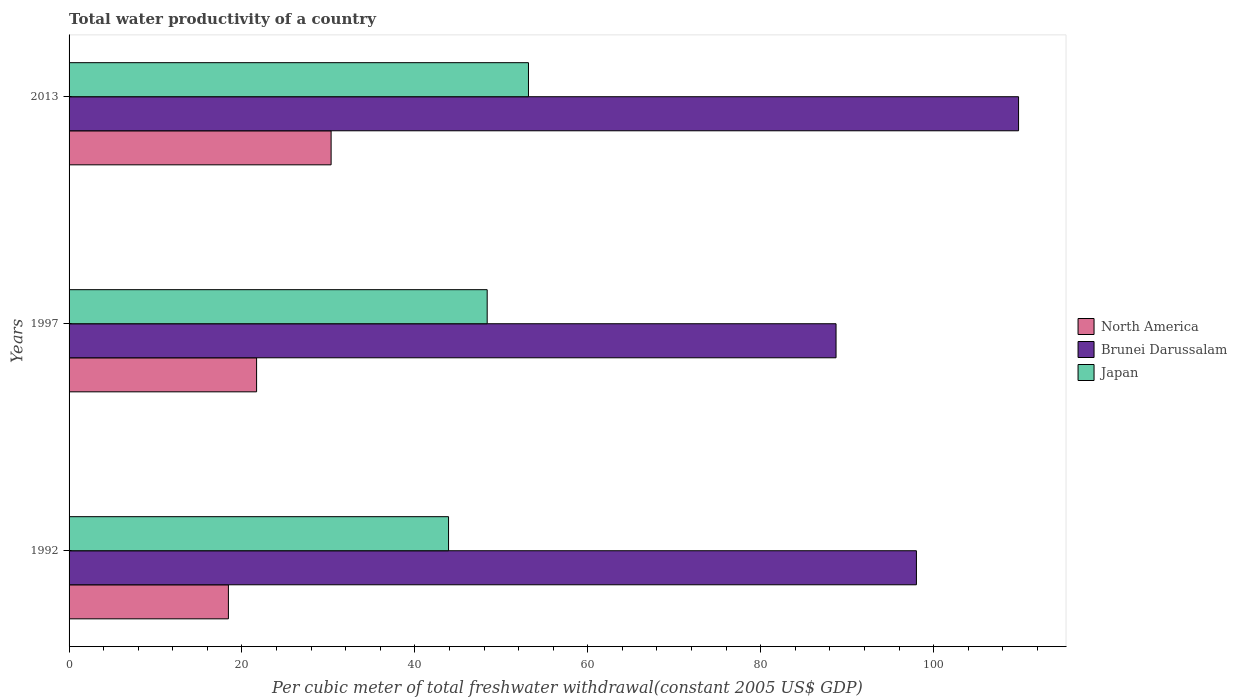How many different coloured bars are there?
Your answer should be compact. 3. How many bars are there on the 2nd tick from the top?
Give a very brief answer. 3. How many bars are there on the 1st tick from the bottom?
Ensure brevity in your answer.  3. In how many cases, is the number of bars for a given year not equal to the number of legend labels?
Ensure brevity in your answer.  0. What is the total water productivity in Brunei Darussalam in 1992?
Provide a succinct answer. 98.01. Across all years, what is the maximum total water productivity in Brunei Darussalam?
Give a very brief answer. 109.83. Across all years, what is the minimum total water productivity in Brunei Darussalam?
Your answer should be very brief. 88.71. What is the total total water productivity in Brunei Darussalam in the graph?
Keep it short and to the point. 296.55. What is the difference between the total water productivity in Brunei Darussalam in 1992 and that in 1997?
Provide a succinct answer. 9.3. What is the difference between the total water productivity in Japan in 1992 and the total water productivity in Brunei Darussalam in 2013?
Make the answer very short. -65.93. What is the average total water productivity in North America per year?
Your answer should be compact. 23.48. In the year 1992, what is the difference between the total water productivity in Japan and total water productivity in Brunei Darussalam?
Provide a succinct answer. -54.12. In how many years, is the total water productivity in North America greater than 92 US$?
Give a very brief answer. 0. What is the ratio of the total water productivity in Brunei Darussalam in 1992 to that in 2013?
Keep it short and to the point. 0.89. Is the difference between the total water productivity in Japan in 1992 and 2013 greater than the difference between the total water productivity in Brunei Darussalam in 1992 and 2013?
Ensure brevity in your answer.  Yes. What is the difference between the highest and the second highest total water productivity in Brunei Darussalam?
Offer a terse response. 11.81. What is the difference between the highest and the lowest total water productivity in Brunei Darussalam?
Your answer should be compact. 21.11. In how many years, is the total water productivity in Brunei Darussalam greater than the average total water productivity in Brunei Darussalam taken over all years?
Your answer should be compact. 1. What does the 2nd bar from the bottom in 1992 represents?
Provide a succinct answer. Brunei Darussalam. Is it the case that in every year, the sum of the total water productivity in Brunei Darussalam and total water productivity in North America is greater than the total water productivity in Japan?
Offer a very short reply. Yes. Are all the bars in the graph horizontal?
Provide a short and direct response. Yes. How many years are there in the graph?
Keep it short and to the point. 3. Does the graph contain any zero values?
Your response must be concise. No. Does the graph contain grids?
Offer a terse response. No. Where does the legend appear in the graph?
Provide a short and direct response. Center right. How many legend labels are there?
Ensure brevity in your answer.  3. How are the legend labels stacked?
Ensure brevity in your answer.  Vertical. What is the title of the graph?
Your response must be concise. Total water productivity of a country. What is the label or title of the X-axis?
Give a very brief answer. Per cubic meter of total freshwater withdrawal(constant 2005 US$ GDP). What is the Per cubic meter of total freshwater withdrawal(constant 2005 US$ GDP) in North America in 1992?
Provide a succinct answer. 18.43. What is the Per cubic meter of total freshwater withdrawal(constant 2005 US$ GDP) in Brunei Darussalam in 1992?
Your answer should be very brief. 98.01. What is the Per cubic meter of total freshwater withdrawal(constant 2005 US$ GDP) in Japan in 1992?
Make the answer very short. 43.89. What is the Per cubic meter of total freshwater withdrawal(constant 2005 US$ GDP) of North America in 1997?
Ensure brevity in your answer.  21.69. What is the Per cubic meter of total freshwater withdrawal(constant 2005 US$ GDP) of Brunei Darussalam in 1997?
Offer a very short reply. 88.71. What is the Per cubic meter of total freshwater withdrawal(constant 2005 US$ GDP) in Japan in 1997?
Your answer should be very brief. 48.36. What is the Per cubic meter of total freshwater withdrawal(constant 2005 US$ GDP) of North America in 2013?
Your answer should be very brief. 30.31. What is the Per cubic meter of total freshwater withdrawal(constant 2005 US$ GDP) of Brunei Darussalam in 2013?
Your answer should be very brief. 109.83. What is the Per cubic meter of total freshwater withdrawal(constant 2005 US$ GDP) in Japan in 2013?
Offer a very short reply. 53.14. Across all years, what is the maximum Per cubic meter of total freshwater withdrawal(constant 2005 US$ GDP) of North America?
Your response must be concise. 30.31. Across all years, what is the maximum Per cubic meter of total freshwater withdrawal(constant 2005 US$ GDP) in Brunei Darussalam?
Offer a very short reply. 109.83. Across all years, what is the maximum Per cubic meter of total freshwater withdrawal(constant 2005 US$ GDP) of Japan?
Offer a very short reply. 53.14. Across all years, what is the minimum Per cubic meter of total freshwater withdrawal(constant 2005 US$ GDP) in North America?
Offer a very short reply. 18.43. Across all years, what is the minimum Per cubic meter of total freshwater withdrawal(constant 2005 US$ GDP) in Brunei Darussalam?
Your response must be concise. 88.71. Across all years, what is the minimum Per cubic meter of total freshwater withdrawal(constant 2005 US$ GDP) in Japan?
Give a very brief answer. 43.89. What is the total Per cubic meter of total freshwater withdrawal(constant 2005 US$ GDP) in North America in the graph?
Offer a very short reply. 70.43. What is the total Per cubic meter of total freshwater withdrawal(constant 2005 US$ GDP) in Brunei Darussalam in the graph?
Offer a very short reply. 296.55. What is the total Per cubic meter of total freshwater withdrawal(constant 2005 US$ GDP) of Japan in the graph?
Keep it short and to the point. 145.39. What is the difference between the Per cubic meter of total freshwater withdrawal(constant 2005 US$ GDP) of North America in 1992 and that in 1997?
Keep it short and to the point. -3.26. What is the difference between the Per cubic meter of total freshwater withdrawal(constant 2005 US$ GDP) in Brunei Darussalam in 1992 and that in 1997?
Make the answer very short. 9.3. What is the difference between the Per cubic meter of total freshwater withdrawal(constant 2005 US$ GDP) of Japan in 1992 and that in 1997?
Offer a terse response. -4.47. What is the difference between the Per cubic meter of total freshwater withdrawal(constant 2005 US$ GDP) in North America in 1992 and that in 2013?
Ensure brevity in your answer.  -11.88. What is the difference between the Per cubic meter of total freshwater withdrawal(constant 2005 US$ GDP) in Brunei Darussalam in 1992 and that in 2013?
Ensure brevity in your answer.  -11.81. What is the difference between the Per cubic meter of total freshwater withdrawal(constant 2005 US$ GDP) of Japan in 1992 and that in 2013?
Your response must be concise. -9.24. What is the difference between the Per cubic meter of total freshwater withdrawal(constant 2005 US$ GDP) of North America in 1997 and that in 2013?
Offer a very short reply. -8.62. What is the difference between the Per cubic meter of total freshwater withdrawal(constant 2005 US$ GDP) of Brunei Darussalam in 1997 and that in 2013?
Provide a short and direct response. -21.11. What is the difference between the Per cubic meter of total freshwater withdrawal(constant 2005 US$ GDP) in Japan in 1997 and that in 2013?
Offer a terse response. -4.78. What is the difference between the Per cubic meter of total freshwater withdrawal(constant 2005 US$ GDP) of North America in 1992 and the Per cubic meter of total freshwater withdrawal(constant 2005 US$ GDP) of Brunei Darussalam in 1997?
Make the answer very short. -70.28. What is the difference between the Per cubic meter of total freshwater withdrawal(constant 2005 US$ GDP) of North America in 1992 and the Per cubic meter of total freshwater withdrawal(constant 2005 US$ GDP) of Japan in 1997?
Offer a very short reply. -29.93. What is the difference between the Per cubic meter of total freshwater withdrawal(constant 2005 US$ GDP) in Brunei Darussalam in 1992 and the Per cubic meter of total freshwater withdrawal(constant 2005 US$ GDP) in Japan in 1997?
Provide a short and direct response. 49.65. What is the difference between the Per cubic meter of total freshwater withdrawal(constant 2005 US$ GDP) of North America in 1992 and the Per cubic meter of total freshwater withdrawal(constant 2005 US$ GDP) of Brunei Darussalam in 2013?
Your answer should be compact. -91.4. What is the difference between the Per cubic meter of total freshwater withdrawal(constant 2005 US$ GDP) of North America in 1992 and the Per cubic meter of total freshwater withdrawal(constant 2005 US$ GDP) of Japan in 2013?
Offer a very short reply. -34.71. What is the difference between the Per cubic meter of total freshwater withdrawal(constant 2005 US$ GDP) of Brunei Darussalam in 1992 and the Per cubic meter of total freshwater withdrawal(constant 2005 US$ GDP) of Japan in 2013?
Offer a terse response. 44.87. What is the difference between the Per cubic meter of total freshwater withdrawal(constant 2005 US$ GDP) in North America in 1997 and the Per cubic meter of total freshwater withdrawal(constant 2005 US$ GDP) in Brunei Darussalam in 2013?
Your answer should be very brief. -88.14. What is the difference between the Per cubic meter of total freshwater withdrawal(constant 2005 US$ GDP) of North America in 1997 and the Per cubic meter of total freshwater withdrawal(constant 2005 US$ GDP) of Japan in 2013?
Provide a short and direct response. -31.45. What is the difference between the Per cubic meter of total freshwater withdrawal(constant 2005 US$ GDP) in Brunei Darussalam in 1997 and the Per cubic meter of total freshwater withdrawal(constant 2005 US$ GDP) in Japan in 2013?
Your response must be concise. 35.58. What is the average Per cubic meter of total freshwater withdrawal(constant 2005 US$ GDP) in North America per year?
Offer a terse response. 23.48. What is the average Per cubic meter of total freshwater withdrawal(constant 2005 US$ GDP) of Brunei Darussalam per year?
Offer a very short reply. 98.85. What is the average Per cubic meter of total freshwater withdrawal(constant 2005 US$ GDP) of Japan per year?
Ensure brevity in your answer.  48.46. In the year 1992, what is the difference between the Per cubic meter of total freshwater withdrawal(constant 2005 US$ GDP) of North America and Per cubic meter of total freshwater withdrawal(constant 2005 US$ GDP) of Brunei Darussalam?
Your answer should be compact. -79.58. In the year 1992, what is the difference between the Per cubic meter of total freshwater withdrawal(constant 2005 US$ GDP) in North America and Per cubic meter of total freshwater withdrawal(constant 2005 US$ GDP) in Japan?
Ensure brevity in your answer.  -25.46. In the year 1992, what is the difference between the Per cubic meter of total freshwater withdrawal(constant 2005 US$ GDP) of Brunei Darussalam and Per cubic meter of total freshwater withdrawal(constant 2005 US$ GDP) of Japan?
Make the answer very short. 54.12. In the year 1997, what is the difference between the Per cubic meter of total freshwater withdrawal(constant 2005 US$ GDP) in North America and Per cubic meter of total freshwater withdrawal(constant 2005 US$ GDP) in Brunei Darussalam?
Keep it short and to the point. -67.02. In the year 1997, what is the difference between the Per cubic meter of total freshwater withdrawal(constant 2005 US$ GDP) of North America and Per cubic meter of total freshwater withdrawal(constant 2005 US$ GDP) of Japan?
Make the answer very short. -26.67. In the year 1997, what is the difference between the Per cubic meter of total freshwater withdrawal(constant 2005 US$ GDP) of Brunei Darussalam and Per cubic meter of total freshwater withdrawal(constant 2005 US$ GDP) of Japan?
Provide a succinct answer. 40.35. In the year 2013, what is the difference between the Per cubic meter of total freshwater withdrawal(constant 2005 US$ GDP) in North America and Per cubic meter of total freshwater withdrawal(constant 2005 US$ GDP) in Brunei Darussalam?
Keep it short and to the point. -79.52. In the year 2013, what is the difference between the Per cubic meter of total freshwater withdrawal(constant 2005 US$ GDP) of North America and Per cubic meter of total freshwater withdrawal(constant 2005 US$ GDP) of Japan?
Provide a short and direct response. -22.83. In the year 2013, what is the difference between the Per cubic meter of total freshwater withdrawal(constant 2005 US$ GDP) in Brunei Darussalam and Per cubic meter of total freshwater withdrawal(constant 2005 US$ GDP) in Japan?
Ensure brevity in your answer.  56.69. What is the ratio of the Per cubic meter of total freshwater withdrawal(constant 2005 US$ GDP) in North America in 1992 to that in 1997?
Your answer should be compact. 0.85. What is the ratio of the Per cubic meter of total freshwater withdrawal(constant 2005 US$ GDP) of Brunei Darussalam in 1992 to that in 1997?
Give a very brief answer. 1.1. What is the ratio of the Per cubic meter of total freshwater withdrawal(constant 2005 US$ GDP) in Japan in 1992 to that in 1997?
Keep it short and to the point. 0.91. What is the ratio of the Per cubic meter of total freshwater withdrawal(constant 2005 US$ GDP) of North America in 1992 to that in 2013?
Offer a terse response. 0.61. What is the ratio of the Per cubic meter of total freshwater withdrawal(constant 2005 US$ GDP) of Brunei Darussalam in 1992 to that in 2013?
Your answer should be very brief. 0.89. What is the ratio of the Per cubic meter of total freshwater withdrawal(constant 2005 US$ GDP) in Japan in 1992 to that in 2013?
Ensure brevity in your answer.  0.83. What is the ratio of the Per cubic meter of total freshwater withdrawal(constant 2005 US$ GDP) of North America in 1997 to that in 2013?
Your answer should be compact. 0.72. What is the ratio of the Per cubic meter of total freshwater withdrawal(constant 2005 US$ GDP) of Brunei Darussalam in 1997 to that in 2013?
Provide a short and direct response. 0.81. What is the ratio of the Per cubic meter of total freshwater withdrawal(constant 2005 US$ GDP) of Japan in 1997 to that in 2013?
Your answer should be compact. 0.91. What is the difference between the highest and the second highest Per cubic meter of total freshwater withdrawal(constant 2005 US$ GDP) in North America?
Your answer should be very brief. 8.62. What is the difference between the highest and the second highest Per cubic meter of total freshwater withdrawal(constant 2005 US$ GDP) in Brunei Darussalam?
Provide a succinct answer. 11.81. What is the difference between the highest and the second highest Per cubic meter of total freshwater withdrawal(constant 2005 US$ GDP) in Japan?
Offer a terse response. 4.78. What is the difference between the highest and the lowest Per cubic meter of total freshwater withdrawal(constant 2005 US$ GDP) in North America?
Provide a short and direct response. 11.88. What is the difference between the highest and the lowest Per cubic meter of total freshwater withdrawal(constant 2005 US$ GDP) in Brunei Darussalam?
Offer a terse response. 21.11. What is the difference between the highest and the lowest Per cubic meter of total freshwater withdrawal(constant 2005 US$ GDP) in Japan?
Ensure brevity in your answer.  9.24. 